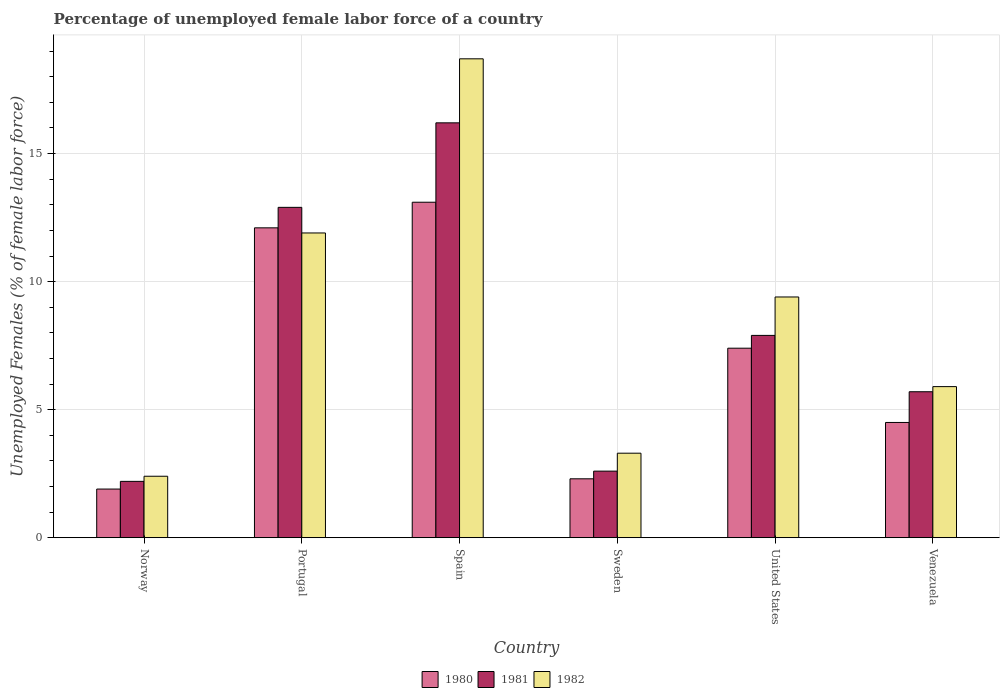How many different coloured bars are there?
Provide a succinct answer. 3. How many groups of bars are there?
Offer a terse response. 6. What is the label of the 6th group of bars from the left?
Keep it short and to the point. Venezuela. What is the percentage of unemployed female labor force in 1981 in Sweden?
Provide a short and direct response. 2.6. Across all countries, what is the maximum percentage of unemployed female labor force in 1982?
Provide a short and direct response. 18.7. Across all countries, what is the minimum percentage of unemployed female labor force in 1982?
Provide a short and direct response. 2.4. In which country was the percentage of unemployed female labor force in 1981 maximum?
Your answer should be very brief. Spain. What is the total percentage of unemployed female labor force in 1982 in the graph?
Offer a very short reply. 51.6. What is the difference between the percentage of unemployed female labor force in 1982 in Norway and that in Portugal?
Make the answer very short. -9.5. What is the difference between the percentage of unemployed female labor force in 1981 in Sweden and the percentage of unemployed female labor force in 1980 in Portugal?
Offer a very short reply. -9.5. What is the average percentage of unemployed female labor force in 1980 per country?
Keep it short and to the point. 6.88. What is the difference between the percentage of unemployed female labor force of/in 1980 and percentage of unemployed female labor force of/in 1982 in Portugal?
Provide a succinct answer. 0.2. What is the ratio of the percentage of unemployed female labor force in 1982 in Norway to that in Sweden?
Keep it short and to the point. 0.73. Is the difference between the percentage of unemployed female labor force in 1980 in Portugal and Spain greater than the difference between the percentage of unemployed female labor force in 1982 in Portugal and Spain?
Provide a succinct answer. Yes. What is the difference between the highest and the second highest percentage of unemployed female labor force in 1982?
Offer a very short reply. -9.3. What is the difference between the highest and the lowest percentage of unemployed female labor force in 1981?
Make the answer very short. 14. In how many countries, is the percentage of unemployed female labor force in 1980 greater than the average percentage of unemployed female labor force in 1980 taken over all countries?
Give a very brief answer. 3. Is the sum of the percentage of unemployed female labor force in 1981 in Spain and Sweden greater than the maximum percentage of unemployed female labor force in 1980 across all countries?
Ensure brevity in your answer.  Yes. What does the 3rd bar from the right in United States represents?
Offer a terse response. 1980. Is it the case that in every country, the sum of the percentage of unemployed female labor force in 1981 and percentage of unemployed female labor force in 1982 is greater than the percentage of unemployed female labor force in 1980?
Keep it short and to the point. Yes. How many bars are there?
Offer a terse response. 18. Are all the bars in the graph horizontal?
Ensure brevity in your answer.  No. How many countries are there in the graph?
Offer a terse response. 6. Are the values on the major ticks of Y-axis written in scientific E-notation?
Offer a terse response. No. Does the graph contain grids?
Keep it short and to the point. Yes. How are the legend labels stacked?
Give a very brief answer. Horizontal. What is the title of the graph?
Offer a terse response. Percentage of unemployed female labor force of a country. Does "1995" appear as one of the legend labels in the graph?
Provide a short and direct response. No. What is the label or title of the Y-axis?
Keep it short and to the point. Unemployed Females (% of female labor force). What is the Unemployed Females (% of female labor force) in 1980 in Norway?
Offer a very short reply. 1.9. What is the Unemployed Females (% of female labor force) of 1981 in Norway?
Offer a very short reply. 2.2. What is the Unemployed Females (% of female labor force) in 1982 in Norway?
Keep it short and to the point. 2.4. What is the Unemployed Females (% of female labor force) in 1980 in Portugal?
Ensure brevity in your answer.  12.1. What is the Unemployed Females (% of female labor force) of 1981 in Portugal?
Make the answer very short. 12.9. What is the Unemployed Females (% of female labor force) in 1982 in Portugal?
Provide a succinct answer. 11.9. What is the Unemployed Females (% of female labor force) in 1980 in Spain?
Your answer should be very brief. 13.1. What is the Unemployed Females (% of female labor force) in 1981 in Spain?
Provide a succinct answer. 16.2. What is the Unemployed Females (% of female labor force) of 1982 in Spain?
Offer a terse response. 18.7. What is the Unemployed Females (% of female labor force) of 1980 in Sweden?
Offer a terse response. 2.3. What is the Unemployed Females (% of female labor force) in 1981 in Sweden?
Offer a very short reply. 2.6. What is the Unemployed Females (% of female labor force) in 1982 in Sweden?
Provide a short and direct response. 3.3. What is the Unemployed Females (% of female labor force) in 1980 in United States?
Give a very brief answer. 7.4. What is the Unemployed Females (% of female labor force) of 1981 in United States?
Offer a terse response. 7.9. What is the Unemployed Females (% of female labor force) in 1982 in United States?
Make the answer very short. 9.4. What is the Unemployed Females (% of female labor force) in 1980 in Venezuela?
Give a very brief answer. 4.5. What is the Unemployed Females (% of female labor force) in 1981 in Venezuela?
Your answer should be compact. 5.7. What is the Unemployed Females (% of female labor force) of 1982 in Venezuela?
Provide a succinct answer. 5.9. Across all countries, what is the maximum Unemployed Females (% of female labor force) of 1980?
Provide a succinct answer. 13.1. Across all countries, what is the maximum Unemployed Females (% of female labor force) in 1981?
Keep it short and to the point. 16.2. Across all countries, what is the maximum Unemployed Females (% of female labor force) of 1982?
Provide a short and direct response. 18.7. Across all countries, what is the minimum Unemployed Females (% of female labor force) of 1980?
Ensure brevity in your answer.  1.9. Across all countries, what is the minimum Unemployed Females (% of female labor force) of 1981?
Offer a very short reply. 2.2. Across all countries, what is the minimum Unemployed Females (% of female labor force) in 1982?
Your answer should be very brief. 2.4. What is the total Unemployed Females (% of female labor force) in 1980 in the graph?
Keep it short and to the point. 41.3. What is the total Unemployed Females (% of female labor force) of 1981 in the graph?
Your response must be concise. 47.5. What is the total Unemployed Females (% of female labor force) in 1982 in the graph?
Offer a terse response. 51.6. What is the difference between the Unemployed Females (% of female labor force) in 1981 in Norway and that in Portugal?
Your answer should be compact. -10.7. What is the difference between the Unemployed Females (% of female labor force) of 1980 in Norway and that in Spain?
Make the answer very short. -11.2. What is the difference between the Unemployed Females (% of female labor force) of 1982 in Norway and that in Spain?
Give a very brief answer. -16.3. What is the difference between the Unemployed Females (% of female labor force) in 1980 in Norway and that in Sweden?
Provide a succinct answer. -0.4. What is the difference between the Unemployed Females (% of female labor force) of 1982 in Norway and that in Sweden?
Offer a terse response. -0.9. What is the difference between the Unemployed Females (% of female labor force) of 1982 in Norway and that in United States?
Keep it short and to the point. -7. What is the difference between the Unemployed Females (% of female labor force) of 1980 in Norway and that in Venezuela?
Make the answer very short. -2.6. What is the difference between the Unemployed Females (% of female labor force) in 1981 in Norway and that in Venezuela?
Your response must be concise. -3.5. What is the difference between the Unemployed Females (% of female labor force) in 1981 in Portugal and that in Spain?
Keep it short and to the point. -3.3. What is the difference between the Unemployed Females (% of female labor force) in 1982 in Portugal and that in Spain?
Offer a very short reply. -6.8. What is the difference between the Unemployed Females (% of female labor force) in 1980 in Portugal and that in Sweden?
Ensure brevity in your answer.  9.8. What is the difference between the Unemployed Females (% of female labor force) in 1981 in Portugal and that in Sweden?
Your answer should be compact. 10.3. What is the difference between the Unemployed Females (% of female labor force) in 1980 in Portugal and that in United States?
Ensure brevity in your answer.  4.7. What is the difference between the Unemployed Females (% of female labor force) in 1982 in Portugal and that in United States?
Ensure brevity in your answer.  2.5. What is the difference between the Unemployed Females (% of female labor force) in 1982 in Portugal and that in Venezuela?
Your answer should be compact. 6. What is the difference between the Unemployed Females (% of female labor force) of 1981 in Spain and that in Sweden?
Your answer should be compact. 13.6. What is the difference between the Unemployed Females (% of female labor force) of 1981 in Sweden and that in United States?
Ensure brevity in your answer.  -5.3. What is the difference between the Unemployed Females (% of female labor force) of 1982 in Sweden and that in United States?
Offer a very short reply. -6.1. What is the difference between the Unemployed Females (% of female labor force) of 1982 in United States and that in Venezuela?
Offer a very short reply. 3.5. What is the difference between the Unemployed Females (% of female labor force) of 1980 in Norway and the Unemployed Females (% of female labor force) of 1981 in Spain?
Keep it short and to the point. -14.3. What is the difference between the Unemployed Females (% of female labor force) of 1980 in Norway and the Unemployed Females (% of female labor force) of 1982 in Spain?
Your answer should be compact. -16.8. What is the difference between the Unemployed Females (% of female labor force) of 1981 in Norway and the Unemployed Females (% of female labor force) of 1982 in Spain?
Give a very brief answer. -16.5. What is the difference between the Unemployed Females (% of female labor force) of 1980 in Norway and the Unemployed Females (% of female labor force) of 1981 in Sweden?
Your answer should be compact. -0.7. What is the difference between the Unemployed Females (% of female labor force) of 1980 in Norway and the Unemployed Females (% of female labor force) of 1982 in Sweden?
Make the answer very short. -1.4. What is the difference between the Unemployed Females (% of female labor force) of 1980 in Norway and the Unemployed Females (% of female labor force) of 1981 in United States?
Make the answer very short. -6. What is the difference between the Unemployed Females (% of female labor force) in 1980 in Norway and the Unemployed Females (% of female labor force) in 1982 in United States?
Offer a terse response. -7.5. What is the difference between the Unemployed Females (% of female labor force) in 1981 in Norway and the Unemployed Females (% of female labor force) in 1982 in United States?
Provide a short and direct response. -7.2. What is the difference between the Unemployed Females (% of female labor force) in 1980 in Norway and the Unemployed Females (% of female labor force) in 1981 in Venezuela?
Your response must be concise. -3.8. What is the difference between the Unemployed Females (% of female labor force) of 1981 in Norway and the Unemployed Females (% of female labor force) of 1982 in Venezuela?
Provide a succinct answer. -3.7. What is the difference between the Unemployed Females (% of female labor force) in 1980 in Portugal and the Unemployed Females (% of female labor force) in 1982 in Spain?
Make the answer very short. -6.6. What is the difference between the Unemployed Females (% of female labor force) of 1981 in Portugal and the Unemployed Females (% of female labor force) of 1982 in Spain?
Your answer should be very brief. -5.8. What is the difference between the Unemployed Females (% of female labor force) of 1980 in Portugal and the Unemployed Females (% of female labor force) of 1981 in Sweden?
Offer a very short reply. 9.5. What is the difference between the Unemployed Females (% of female labor force) of 1980 in Portugal and the Unemployed Females (% of female labor force) of 1982 in Sweden?
Give a very brief answer. 8.8. What is the difference between the Unemployed Females (% of female labor force) of 1981 in Portugal and the Unemployed Females (% of female labor force) of 1982 in Sweden?
Offer a very short reply. 9.6. What is the difference between the Unemployed Females (% of female labor force) of 1980 in Portugal and the Unemployed Females (% of female labor force) of 1982 in United States?
Keep it short and to the point. 2.7. What is the difference between the Unemployed Females (% of female labor force) in 1981 in Portugal and the Unemployed Females (% of female labor force) in 1982 in United States?
Provide a succinct answer. 3.5. What is the difference between the Unemployed Females (% of female labor force) of 1980 in Portugal and the Unemployed Females (% of female labor force) of 1982 in Venezuela?
Keep it short and to the point. 6.2. What is the difference between the Unemployed Females (% of female labor force) in 1980 in Spain and the Unemployed Females (% of female labor force) in 1981 in Sweden?
Provide a succinct answer. 10.5. What is the difference between the Unemployed Females (% of female labor force) of 1980 in Spain and the Unemployed Females (% of female labor force) of 1981 in United States?
Your answer should be compact. 5.2. What is the difference between the Unemployed Females (% of female labor force) in 1980 in Spain and the Unemployed Females (% of female labor force) in 1981 in Venezuela?
Provide a short and direct response. 7.4. What is the difference between the Unemployed Females (% of female labor force) in 1980 in Spain and the Unemployed Females (% of female labor force) in 1982 in Venezuela?
Your response must be concise. 7.2. What is the difference between the Unemployed Females (% of female labor force) of 1981 in Spain and the Unemployed Females (% of female labor force) of 1982 in Venezuela?
Offer a terse response. 10.3. What is the difference between the Unemployed Females (% of female labor force) in 1981 in Sweden and the Unemployed Females (% of female labor force) in 1982 in United States?
Provide a short and direct response. -6.8. What is the difference between the Unemployed Females (% of female labor force) of 1980 in Sweden and the Unemployed Females (% of female labor force) of 1981 in Venezuela?
Your answer should be very brief. -3.4. What is the difference between the Unemployed Females (% of female labor force) of 1980 in United States and the Unemployed Females (% of female labor force) of 1981 in Venezuela?
Provide a succinct answer. 1.7. What is the average Unemployed Females (% of female labor force) in 1980 per country?
Your answer should be compact. 6.88. What is the average Unemployed Females (% of female labor force) in 1981 per country?
Offer a terse response. 7.92. What is the average Unemployed Females (% of female labor force) in 1982 per country?
Your response must be concise. 8.6. What is the difference between the Unemployed Females (% of female labor force) in 1980 and Unemployed Females (% of female labor force) in 1982 in Norway?
Provide a succinct answer. -0.5. What is the difference between the Unemployed Females (% of female labor force) of 1980 and Unemployed Females (% of female labor force) of 1981 in Portugal?
Provide a short and direct response. -0.8. What is the difference between the Unemployed Females (% of female labor force) of 1980 and Unemployed Females (% of female labor force) of 1982 in Portugal?
Your response must be concise. 0.2. What is the difference between the Unemployed Females (% of female labor force) in 1980 and Unemployed Females (% of female labor force) in 1981 in Spain?
Offer a terse response. -3.1. What is the difference between the Unemployed Females (% of female labor force) of 1980 and Unemployed Females (% of female labor force) of 1982 in Spain?
Your response must be concise. -5.6. What is the difference between the Unemployed Females (% of female labor force) of 1981 and Unemployed Females (% of female labor force) of 1982 in Sweden?
Ensure brevity in your answer.  -0.7. What is the difference between the Unemployed Females (% of female labor force) of 1980 and Unemployed Females (% of female labor force) of 1982 in United States?
Offer a terse response. -2. What is the difference between the Unemployed Females (% of female labor force) of 1981 and Unemployed Females (% of female labor force) of 1982 in United States?
Provide a short and direct response. -1.5. What is the difference between the Unemployed Females (% of female labor force) in 1981 and Unemployed Females (% of female labor force) in 1982 in Venezuela?
Make the answer very short. -0.2. What is the ratio of the Unemployed Females (% of female labor force) in 1980 in Norway to that in Portugal?
Make the answer very short. 0.16. What is the ratio of the Unemployed Females (% of female labor force) in 1981 in Norway to that in Portugal?
Ensure brevity in your answer.  0.17. What is the ratio of the Unemployed Females (% of female labor force) in 1982 in Norway to that in Portugal?
Keep it short and to the point. 0.2. What is the ratio of the Unemployed Females (% of female labor force) in 1980 in Norway to that in Spain?
Your answer should be compact. 0.14. What is the ratio of the Unemployed Females (% of female labor force) in 1981 in Norway to that in Spain?
Your answer should be compact. 0.14. What is the ratio of the Unemployed Females (% of female labor force) in 1982 in Norway to that in Spain?
Give a very brief answer. 0.13. What is the ratio of the Unemployed Females (% of female labor force) in 1980 in Norway to that in Sweden?
Keep it short and to the point. 0.83. What is the ratio of the Unemployed Females (% of female labor force) in 1981 in Norway to that in Sweden?
Provide a succinct answer. 0.85. What is the ratio of the Unemployed Females (% of female labor force) in 1982 in Norway to that in Sweden?
Your response must be concise. 0.73. What is the ratio of the Unemployed Females (% of female labor force) of 1980 in Norway to that in United States?
Offer a very short reply. 0.26. What is the ratio of the Unemployed Females (% of female labor force) of 1981 in Norway to that in United States?
Keep it short and to the point. 0.28. What is the ratio of the Unemployed Females (% of female labor force) in 1982 in Norway to that in United States?
Keep it short and to the point. 0.26. What is the ratio of the Unemployed Females (% of female labor force) of 1980 in Norway to that in Venezuela?
Make the answer very short. 0.42. What is the ratio of the Unemployed Females (% of female labor force) of 1981 in Norway to that in Venezuela?
Provide a short and direct response. 0.39. What is the ratio of the Unemployed Females (% of female labor force) in 1982 in Norway to that in Venezuela?
Provide a short and direct response. 0.41. What is the ratio of the Unemployed Females (% of female labor force) in 1980 in Portugal to that in Spain?
Your answer should be very brief. 0.92. What is the ratio of the Unemployed Females (% of female labor force) in 1981 in Portugal to that in Spain?
Your answer should be very brief. 0.8. What is the ratio of the Unemployed Females (% of female labor force) of 1982 in Portugal to that in Spain?
Give a very brief answer. 0.64. What is the ratio of the Unemployed Females (% of female labor force) in 1980 in Portugal to that in Sweden?
Provide a short and direct response. 5.26. What is the ratio of the Unemployed Females (% of female labor force) in 1981 in Portugal to that in Sweden?
Offer a terse response. 4.96. What is the ratio of the Unemployed Females (% of female labor force) of 1982 in Portugal to that in Sweden?
Your answer should be very brief. 3.61. What is the ratio of the Unemployed Females (% of female labor force) in 1980 in Portugal to that in United States?
Provide a succinct answer. 1.64. What is the ratio of the Unemployed Females (% of female labor force) in 1981 in Portugal to that in United States?
Provide a succinct answer. 1.63. What is the ratio of the Unemployed Females (% of female labor force) of 1982 in Portugal to that in United States?
Your response must be concise. 1.27. What is the ratio of the Unemployed Females (% of female labor force) of 1980 in Portugal to that in Venezuela?
Your answer should be very brief. 2.69. What is the ratio of the Unemployed Females (% of female labor force) in 1981 in Portugal to that in Venezuela?
Give a very brief answer. 2.26. What is the ratio of the Unemployed Females (% of female labor force) of 1982 in Portugal to that in Venezuela?
Offer a very short reply. 2.02. What is the ratio of the Unemployed Females (% of female labor force) of 1980 in Spain to that in Sweden?
Make the answer very short. 5.7. What is the ratio of the Unemployed Females (% of female labor force) of 1981 in Spain to that in Sweden?
Offer a very short reply. 6.23. What is the ratio of the Unemployed Females (% of female labor force) of 1982 in Spain to that in Sweden?
Provide a short and direct response. 5.67. What is the ratio of the Unemployed Females (% of female labor force) in 1980 in Spain to that in United States?
Your answer should be compact. 1.77. What is the ratio of the Unemployed Females (% of female labor force) of 1981 in Spain to that in United States?
Keep it short and to the point. 2.05. What is the ratio of the Unemployed Females (% of female labor force) in 1982 in Spain to that in United States?
Make the answer very short. 1.99. What is the ratio of the Unemployed Females (% of female labor force) of 1980 in Spain to that in Venezuela?
Give a very brief answer. 2.91. What is the ratio of the Unemployed Females (% of female labor force) in 1981 in Spain to that in Venezuela?
Offer a very short reply. 2.84. What is the ratio of the Unemployed Females (% of female labor force) of 1982 in Spain to that in Venezuela?
Give a very brief answer. 3.17. What is the ratio of the Unemployed Females (% of female labor force) of 1980 in Sweden to that in United States?
Keep it short and to the point. 0.31. What is the ratio of the Unemployed Females (% of female labor force) in 1981 in Sweden to that in United States?
Give a very brief answer. 0.33. What is the ratio of the Unemployed Females (% of female labor force) of 1982 in Sweden to that in United States?
Offer a very short reply. 0.35. What is the ratio of the Unemployed Females (% of female labor force) in 1980 in Sweden to that in Venezuela?
Offer a very short reply. 0.51. What is the ratio of the Unemployed Females (% of female labor force) in 1981 in Sweden to that in Venezuela?
Make the answer very short. 0.46. What is the ratio of the Unemployed Females (% of female labor force) in 1982 in Sweden to that in Venezuela?
Provide a short and direct response. 0.56. What is the ratio of the Unemployed Females (% of female labor force) in 1980 in United States to that in Venezuela?
Keep it short and to the point. 1.64. What is the ratio of the Unemployed Females (% of female labor force) in 1981 in United States to that in Venezuela?
Your answer should be compact. 1.39. What is the ratio of the Unemployed Females (% of female labor force) in 1982 in United States to that in Venezuela?
Your answer should be compact. 1.59. What is the difference between the highest and the lowest Unemployed Females (% of female labor force) in 1982?
Give a very brief answer. 16.3. 